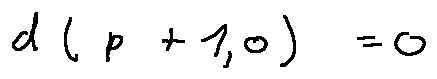<formula> <loc_0><loc_0><loc_500><loc_500>d ( p + 1 , 0 ) = 0</formula> 